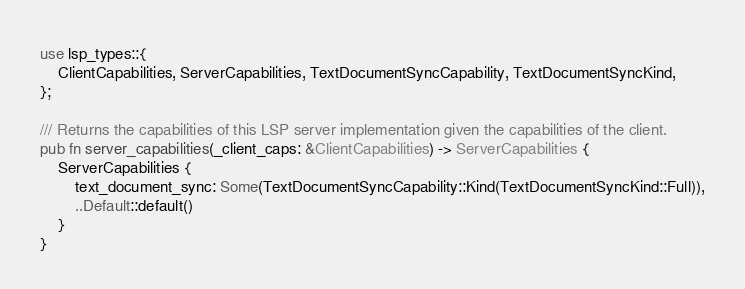<code> <loc_0><loc_0><loc_500><loc_500><_Rust_>use lsp_types::{
    ClientCapabilities, ServerCapabilities, TextDocumentSyncCapability, TextDocumentSyncKind,
};

/// Returns the capabilities of this LSP server implementation given the capabilities of the client.
pub fn server_capabilities(_client_caps: &ClientCapabilities) -> ServerCapabilities {
    ServerCapabilities {
        text_document_sync: Some(TextDocumentSyncCapability::Kind(TextDocumentSyncKind::Full)),
        ..Default::default()
    }
}
</code> 